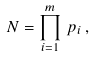Convert formula to latex. <formula><loc_0><loc_0><loc_500><loc_500>N = \prod _ { i = 1 } ^ { m } \, p _ { i } \, ,</formula> 